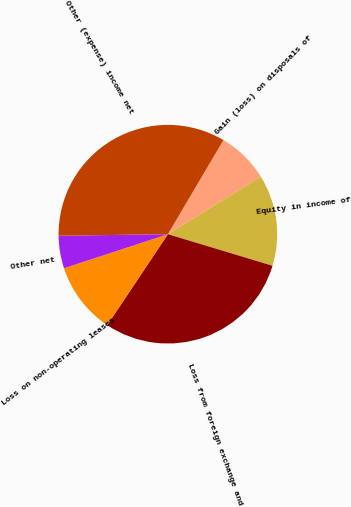<chart> <loc_0><loc_0><loc_500><loc_500><pie_chart><fcel>Gain (loss) on disposals of<fcel>Equity in income of<fcel>Loss from foreign exchange and<fcel>Loss on non-operating leases<fcel>Other net<fcel>Other (expense) income net<nl><fcel>7.7%<fcel>13.48%<fcel>29.7%<fcel>10.59%<fcel>4.82%<fcel>33.71%<nl></chart> 